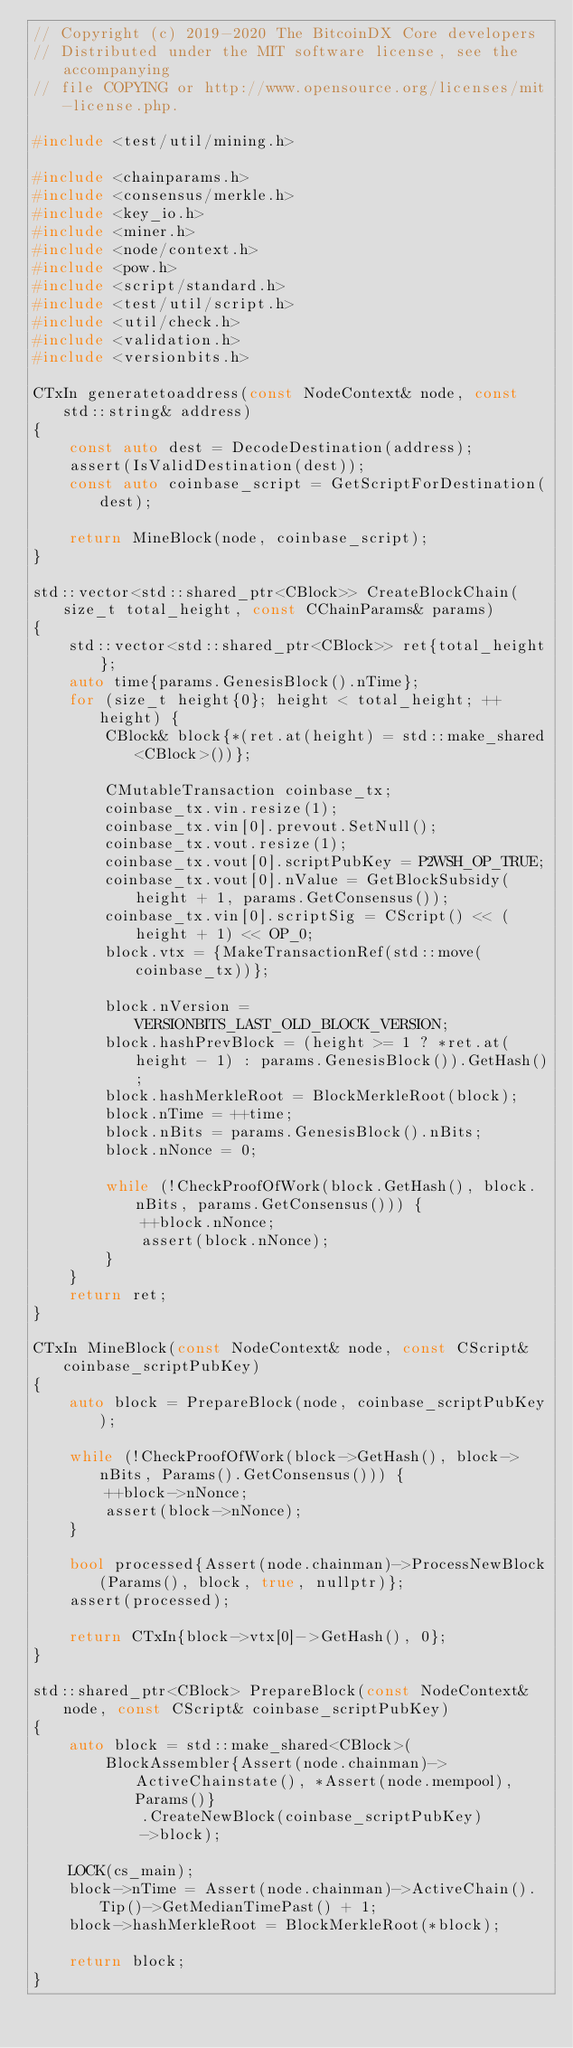Convert code to text. <code><loc_0><loc_0><loc_500><loc_500><_C++_>// Copyright (c) 2019-2020 The BitcoinDX Core developers
// Distributed under the MIT software license, see the accompanying
// file COPYING or http://www.opensource.org/licenses/mit-license.php.

#include <test/util/mining.h>

#include <chainparams.h>
#include <consensus/merkle.h>
#include <key_io.h>
#include <miner.h>
#include <node/context.h>
#include <pow.h>
#include <script/standard.h>
#include <test/util/script.h>
#include <util/check.h>
#include <validation.h>
#include <versionbits.h>

CTxIn generatetoaddress(const NodeContext& node, const std::string& address)
{
    const auto dest = DecodeDestination(address);
    assert(IsValidDestination(dest));
    const auto coinbase_script = GetScriptForDestination(dest);

    return MineBlock(node, coinbase_script);
}

std::vector<std::shared_ptr<CBlock>> CreateBlockChain(size_t total_height, const CChainParams& params)
{
    std::vector<std::shared_ptr<CBlock>> ret{total_height};
    auto time{params.GenesisBlock().nTime};
    for (size_t height{0}; height < total_height; ++height) {
        CBlock& block{*(ret.at(height) = std::make_shared<CBlock>())};

        CMutableTransaction coinbase_tx;
        coinbase_tx.vin.resize(1);
        coinbase_tx.vin[0].prevout.SetNull();
        coinbase_tx.vout.resize(1);
        coinbase_tx.vout[0].scriptPubKey = P2WSH_OP_TRUE;
        coinbase_tx.vout[0].nValue = GetBlockSubsidy(height + 1, params.GetConsensus());
        coinbase_tx.vin[0].scriptSig = CScript() << (height + 1) << OP_0;
        block.vtx = {MakeTransactionRef(std::move(coinbase_tx))};

        block.nVersion = VERSIONBITS_LAST_OLD_BLOCK_VERSION;
        block.hashPrevBlock = (height >= 1 ? *ret.at(height - 1) : params.GenesisBlock()).GetHash();
        block.hashMerkleRoot = BlockMerkleRoot(block);
        block.nTime = ++time;
        block.nBits = params.GenesisBlock().nBits;
        block.nNonce = 0;

        while (!CheckProofOfWork(block.GetHash(), block.nBits, params.GetConsensus())) {
            ++block.nNonce;
            assert(block.nNonce);
        }
    }
    return ret;
}

CTxIn MineBlock(const NodeContext& node, const CScript& coinbase_scriptPubKey)
{
    auto block = PrepareBlock(node, coinbase_scriptPubKey);

    while (!CheckProofOfWork(block->GetHash(), block->nBits, Params().GetConsensus())) {
        ++block->nNonce;
        assert(block->nNonce);
    }

    bool processed{Assert(node.chainman)->ProcessNewBlock(Params(), block, true, nullptr)};
    assert(processed);

    return CTxIn{block->vtx[0]->GetHash(), 0};
}

std::shared_ptr<CBlock> PrepareBlock(const NodeContext& node, const CScript& coinbase_scriptPubKey)
{
    auto block = std::make_shared<CBlock>(
        BlockAssembler{Assert(node.chainman)->ActiveChainstate(), *Assert(node.mempool), Params()}
            .CreateNewBlock(coinbase_scriptPubKey)
            ->block);

    LOCK(cs_main);
    block->nTime = Assert(node.chainman)->ActiveChain().Tip()->GetMedianTimePast() + 1;
    block->hashMerkleRoot = BlockMerkleRoot(*block);

    return block;
}
</code> 